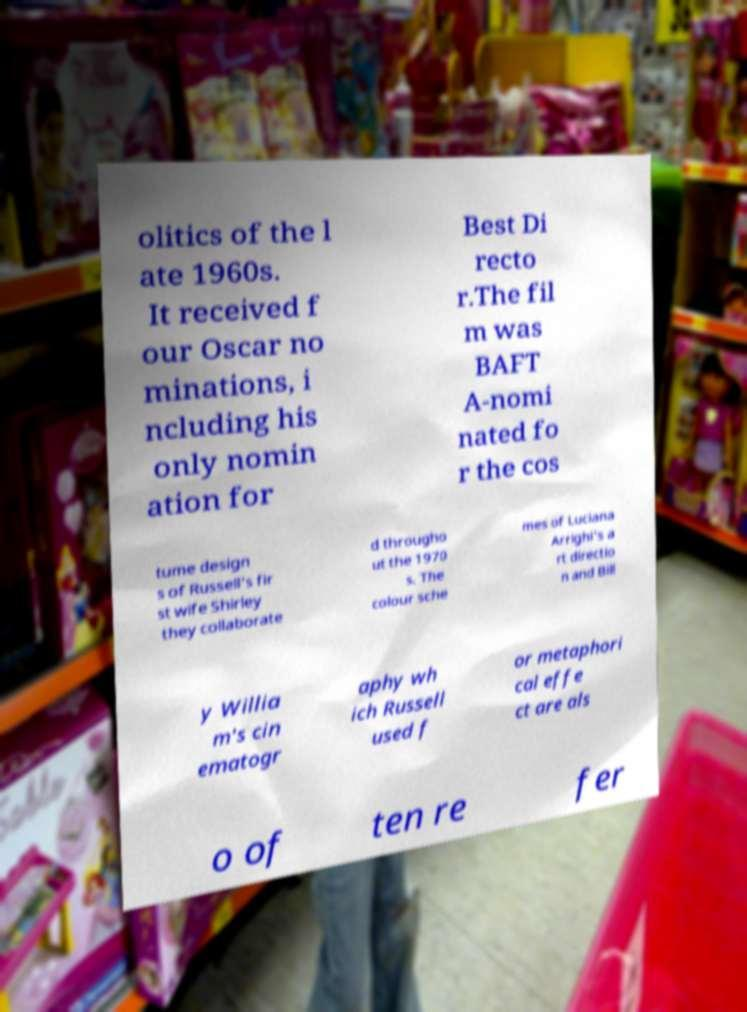For documentation purposes, I need the text within this image transcribed. Could you provide that? olitics of the l ate 1960s. It received f our Oscar no minations, i ncluding his only nomin ation for Best Di recto r.The fil m was BAFT A-nomi nated fo r the cos tume design s of Russell's fir st wife Shirley they collaborate d througho ut the 1970 s. The colour sche mes of Luciana Arrighi's a rt directio n and Bill y Willia m's cin ematogr aphy wh ich Russell used f or metaphori cal effe ct are als o of ten re fer 